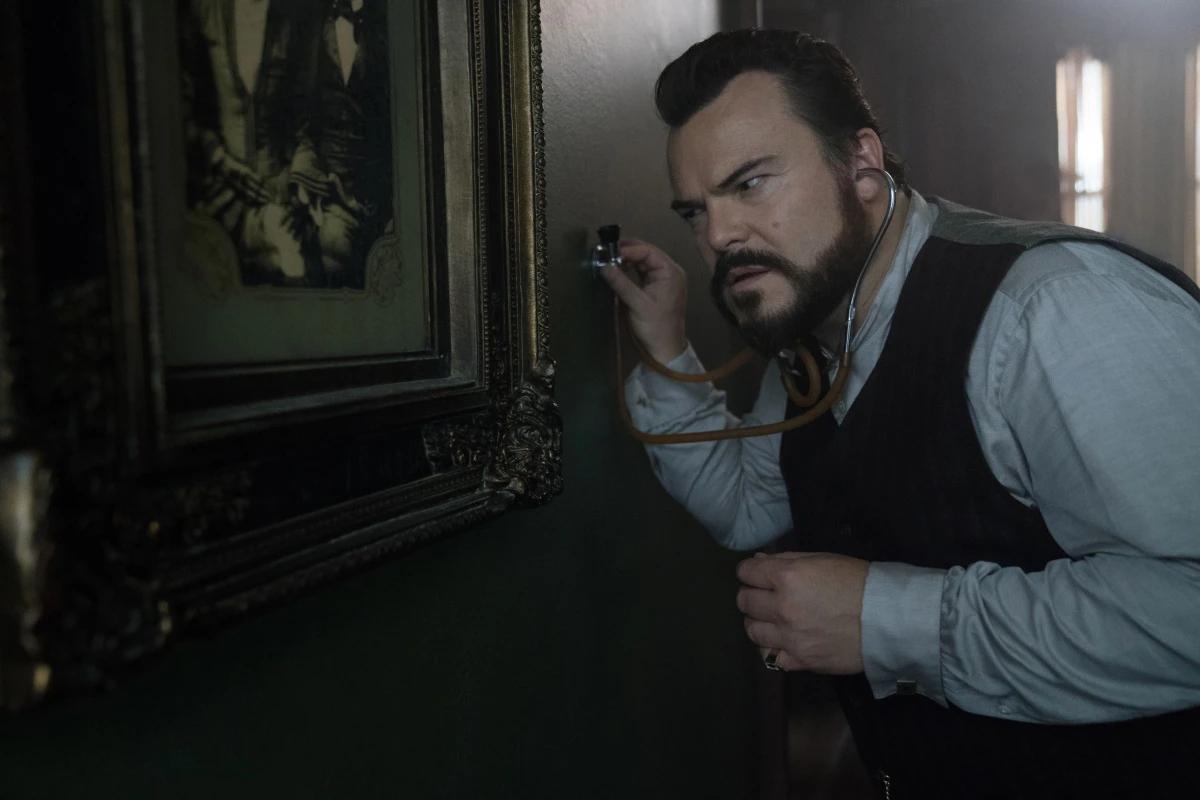What do you think is going on in this snapshot? In this image, we see a man with a contemplative expression. He is dressed in a light shirt, a darker vest, and has a stethoscope around his neck, which suggests that he might be playing a character in a medical or investigative role. He is using the stethoscope to listen carefully near an old, framed photograph on the wall. The photograph appears to be quite old and depicts two men in formal attire. The setting is dimly lit, with an aura of mystery and intrigue. The man's intense focus hints at an attempt to uncover a hidden truth or perhaps eavesdrop on a conversation through the wall. The entire scene exudes a sense of suspense and curiosity. 